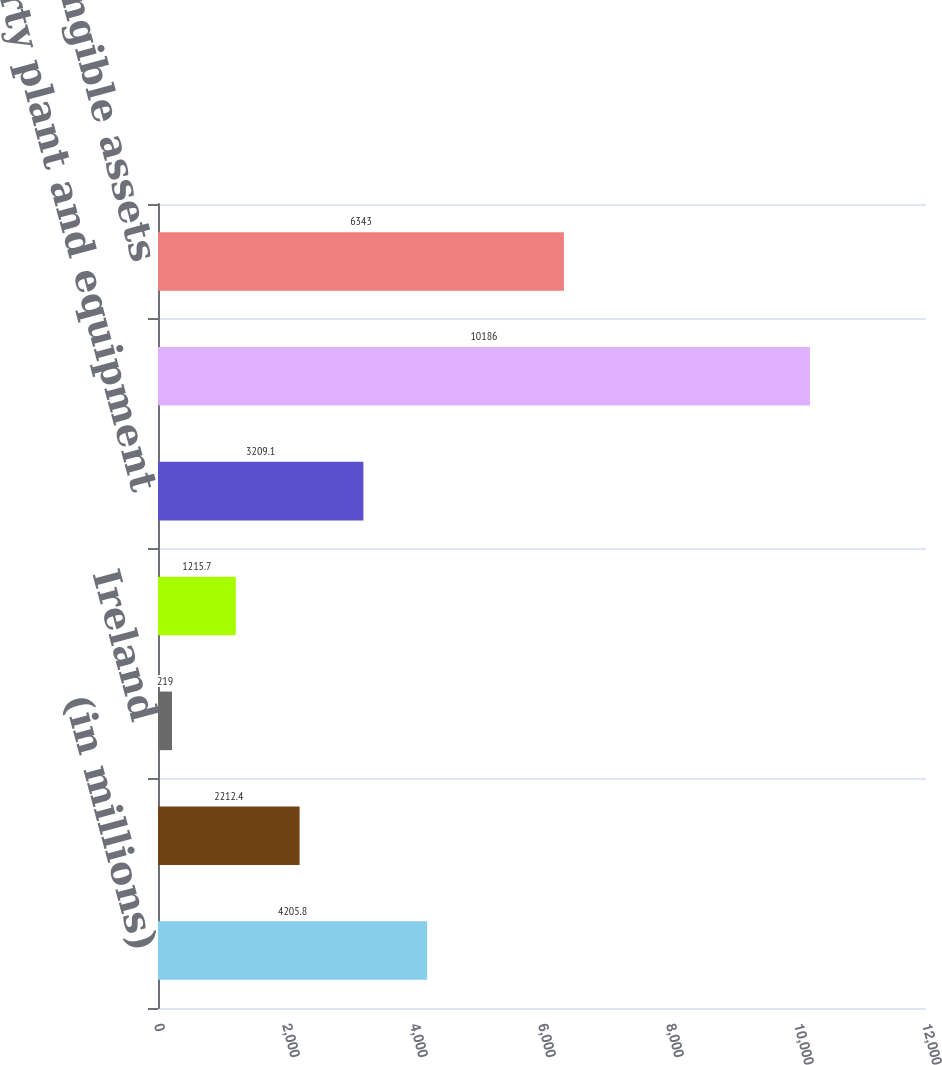Convert chart to OTSL. <chart><loc_0><loc_0><loc_500><loc_500><bar_chart><fcel>(in millions)<fcel>United States<fcel>Ireland<fcel>Other foreign countries<fcel>Property plant and equipment<fcel>Goodwill<fcel>Other intangible assets<nl><fcel>4205.8<fcel>2212.4<fcel>219<fcel>1215.7<fcel>3209.1<fcel>10186<fcel>6343<nl></chart> 